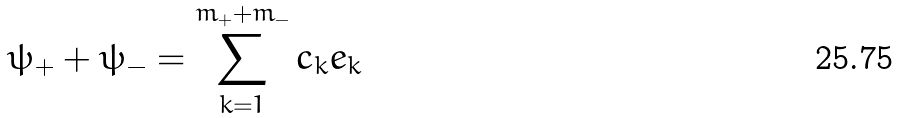<formula> <loc_0><loc_0><loc_500><loc_500>\psi _ { + } + \psi _ { - } = \sum _ { k = 1 } ^ { m _ { + } + m _ { - } } c _ { k } e _ { k }</formula> 